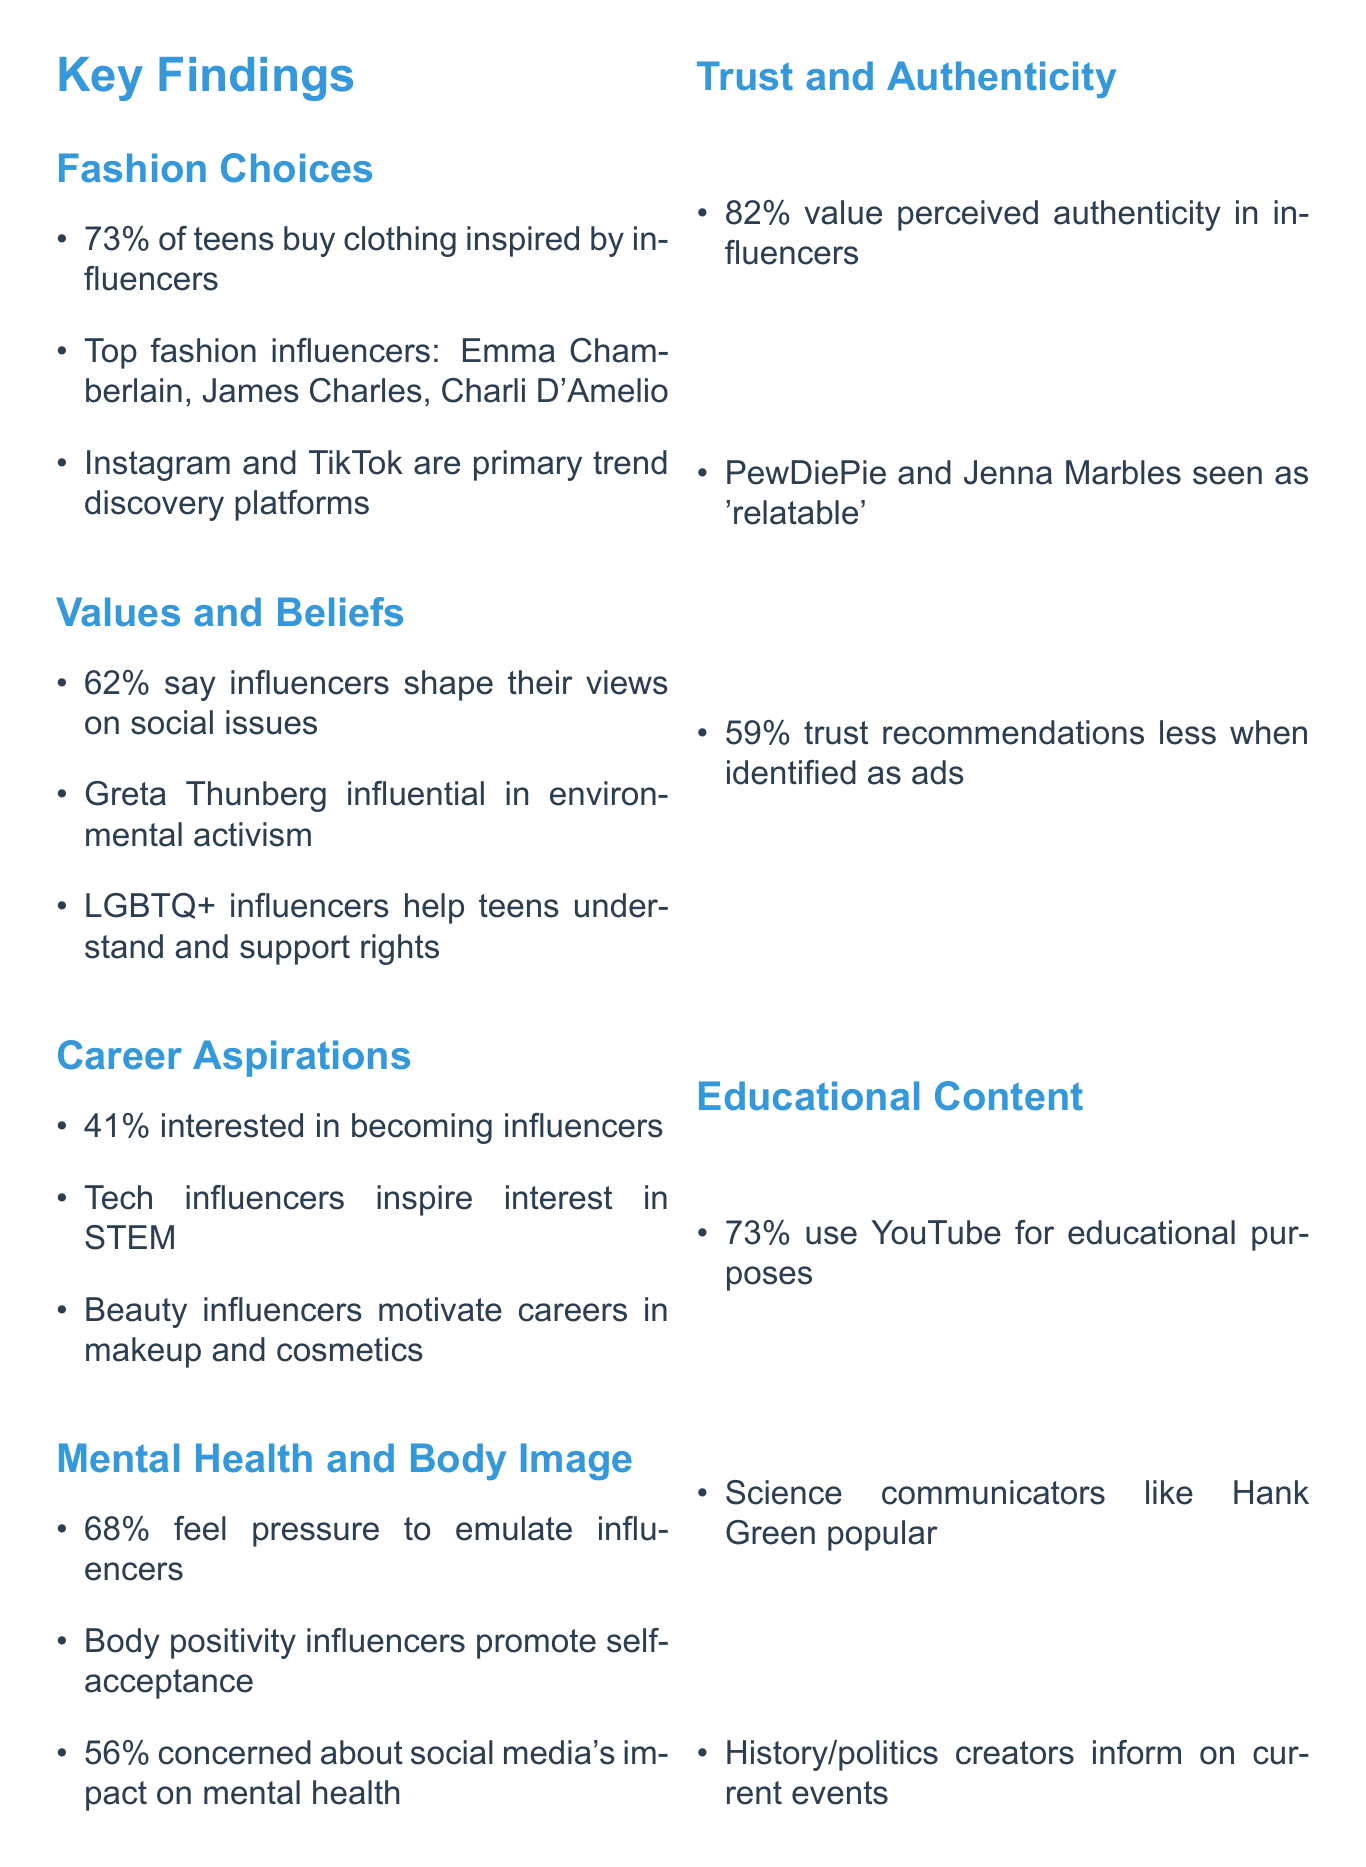What percentage of teens purchase clothing based on influencers? The document states that 73% of interviewed teens reported purchasing clothing or accessories directly inspired by their favorite influencers.
Answer: 73% Who are the top fashion influencers mentioned? The findings list Emma Chamberlain, James Charles, and Charli D'Amelio as examples of popular fashion influencers.
Answer: Emma Chamberlain, James Charles, Charli D'Amelio What social issue influencer significantly shaped teens' views? Greta Thunberg is frequently cited as an influential figure in shaping views on social issues, particularly environmental activism.
Answer: Greta Thunberg What is the percentage of teens concerned about social media's impact on mental health? The document mentions that 56% of teens expressed concern about the potential negative impact of social media on their mental health.
Answer: 56% Which platforms do teens primarily use for discovering fashion trends? The key points indicate that Instagram and TikTok are the primary platforms for discovering fashion trends among teens.
Answer: Instagram and TikTok What percentage of respondents value perceived authenticity in influencers? According to the findings, 82% of interviewed teens valued perceived authenticity in influencers.
Answer: 82% Which type of influencers inspired teens to explore STEM fields? The document notes that tech influencers like Marques Brownlee have inspired interest in STEM fields among teens.
Answer: Tech influencers How many follow-up video interviews were conducted? The methodology section indicates that follow-up video interviews with 50 selected participants were conducted.
Answer: 50 What educational content platform is commonly used by teens? The document states that 73% of respondents reported using YouTube for educational purposes.
Answer: YouTube 